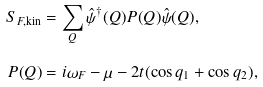Convert formula to latex. <formula><loc_0><loc_0><loc_500><loc_500>S _ { F , \text {kin} } & = \sum _ { Q } \hat { \psi } ^ { \dagger } ( Q ) P ( Q ) \hat { \psi } ( Q ) , \\ P ( Q ) & = i \omega _ { F } - \mu - 2 t ( \cos q _ { 1 } + \cos q _ { 2 } ) ,</formula> 